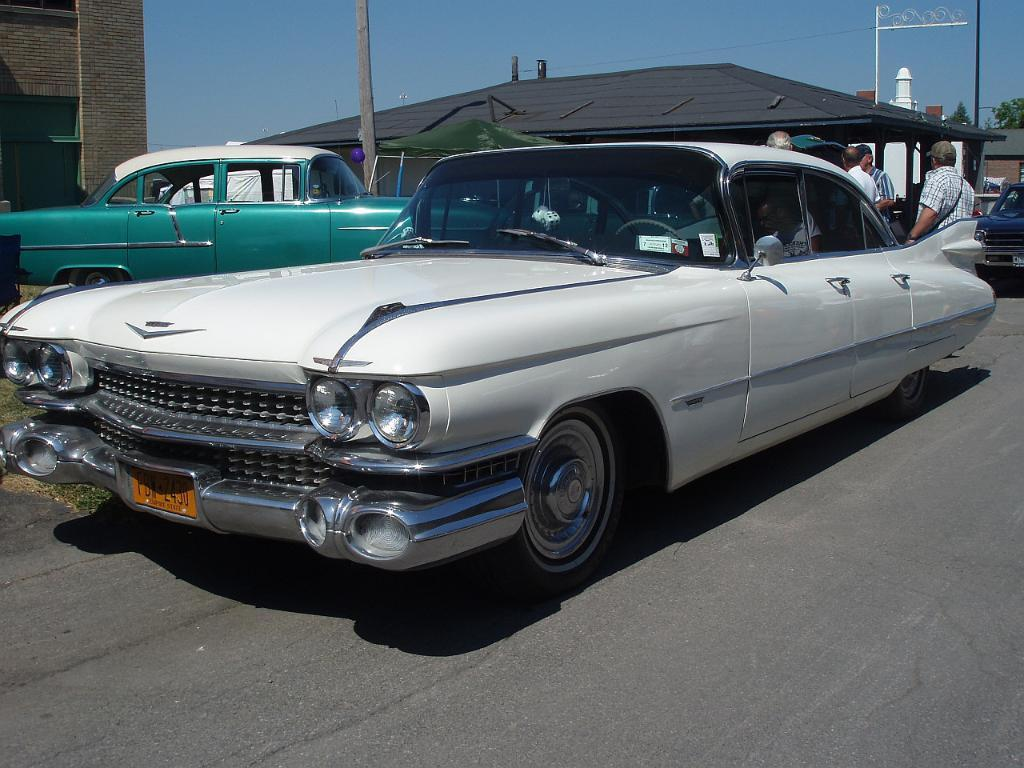What can be seen on the road in the image? There are cars on the road in the image. What is visible in the background of the image? There are people, buildings, trees, and poles in the background of the image. What type of zinc can be seen on the toes of the people in the image? There are no references to zinc or toes in the image, as it primarily features cars on the road and various elements in the background. 